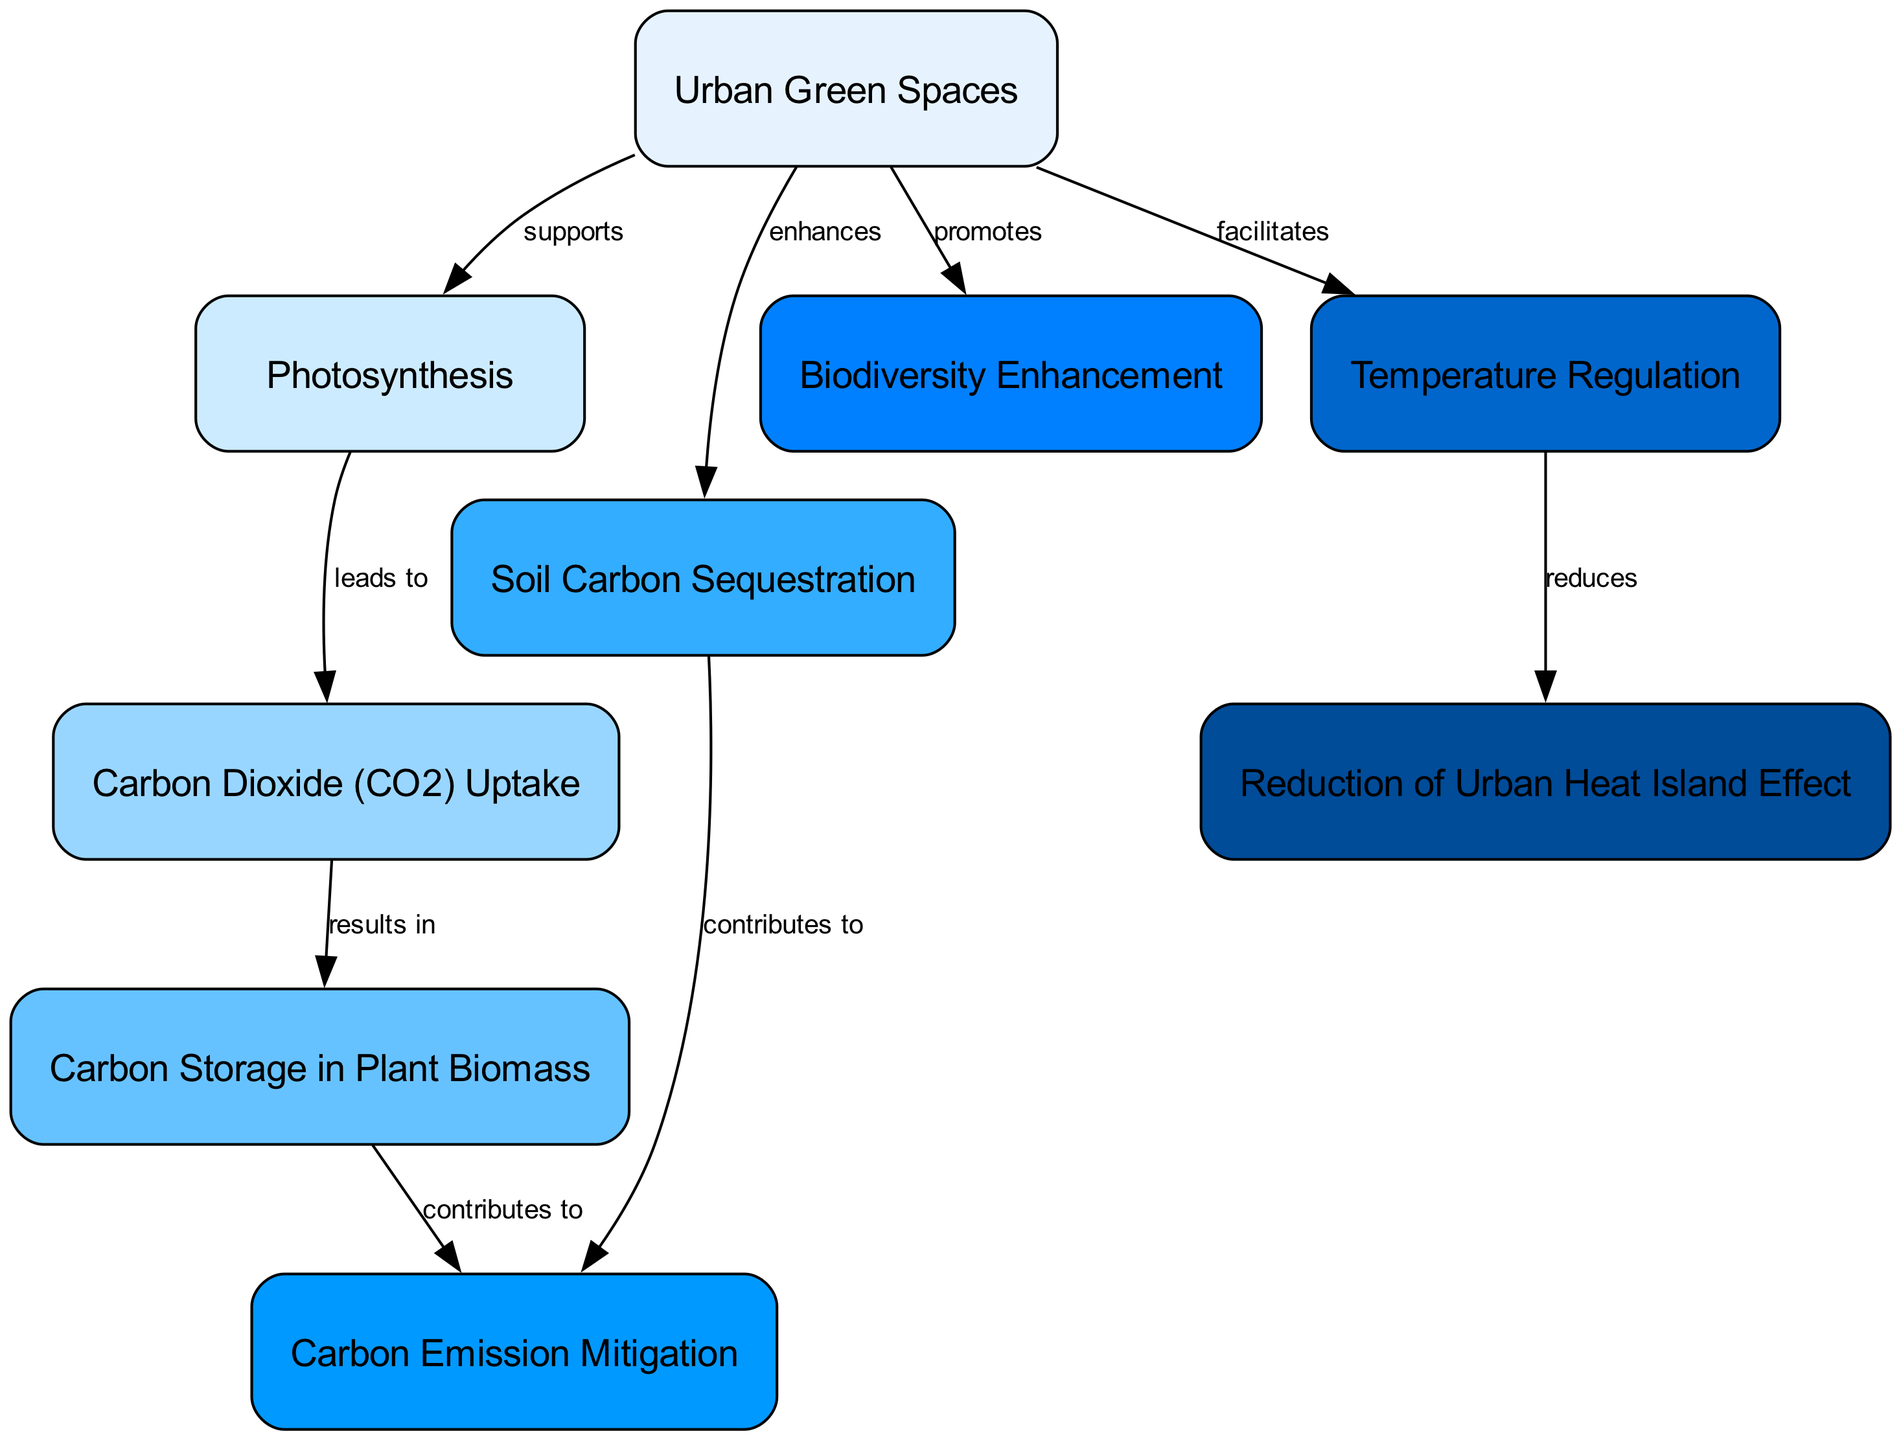What is the total number of nodes in the diagram? By counting the entries under the "nodes" key in the provided data, we find there are nine distinct nodes.
Answer: 9 Which node supports Photosynthesis? The edge that connects "Urban Green Spaces" to "Photosynthesis" indicates that the former supports the latter.
Answer: Urban Green Spaces What does Carbon Dioxide (CO2) Uptake result in? The flow from "Carbon Dioxide (CO2) Uptake" to "Carbon Storage in Plant Biomass" shows that CO2 uptake results in carbon storage.
Answer: Carbon Storage in Plant Biomass How many contributions does Carbon Storage in Plant Biomass make to other processes? By examining the edges, we see that "Carbon Storage in Plant Biomass" contributes to "Carbon Emission Mitigation" (one contribution).
Answer: 1 What role do Urban Green Spaces play in Biodiversity Enhancement? The diagram indicates that Urban Green Spaces promote biodiversity enhancement through a direct edge.
Answer: promotes How does Temperature Regulation reduce the Urban Heat Island Effect? The edge shows a direct relationship where Temperature Regulation leads to a reduction of the Urban Heat Island Effect, indicating causation.
Answer: reduces What two processes are enhanced by Urban Green Spaces? Urban Green Spaces enhance Soil Carbon Sequestration and Biodiversity Enhancement as shown by the direct edges from Urban Green Spaces to these nodes.
Answer: Soil Carbon Sequestration and Biodiversity Enhancement Which process contributes to both Carbon Emission Mitigation and Soil Carbon Sequestration? The edges leading from "Carbon Storage in Plant Biomass" to "Carbon Emission Mitigation" and from "Urban Green Spaces" to "Soil Carbon Sequestration" show that both processes contribute to different aspects of carbon reduction.
Answer: Carbon Storage in Plant Biomass Which two aspects does Urban Green Spaces facilitate? Urban Green Spaces facilitate Photosynthesis and Temperature Regulation, as indicated by separate edges from Urban Green Spaces to these processes.
Answer: Photosynthesis and Temperature Regulation 